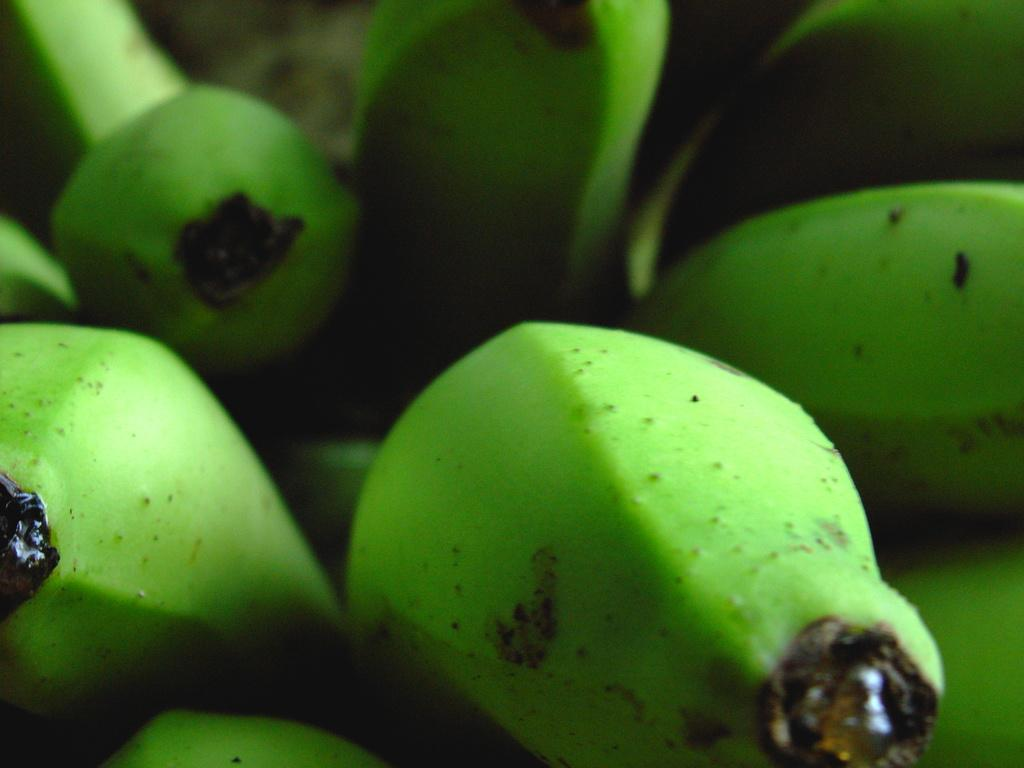What type of fruit is visible in the image? There are green color bananas in the image. Can you describe the quality of the image? The image is blurry in the background. How many girls are playing the instrument in the image? There are no girls or instruments present in the image; it only features green bananas. 